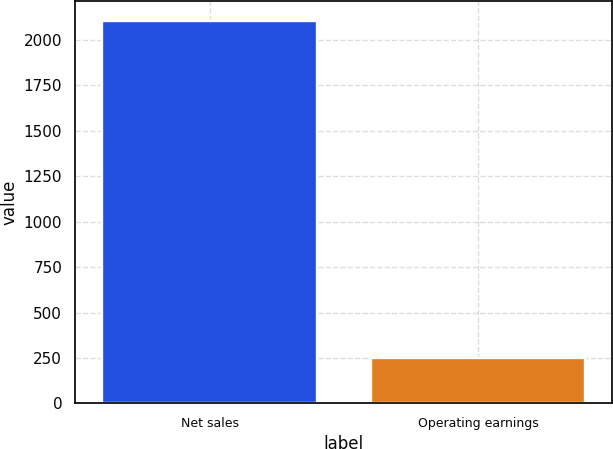<chart> <loc_0><loc_0><loc_500><loc_500><bar_chart><fcel>Net sales<fcel>Operating earnings<nl><fcel>2107<fcel>248<nl></chart> 